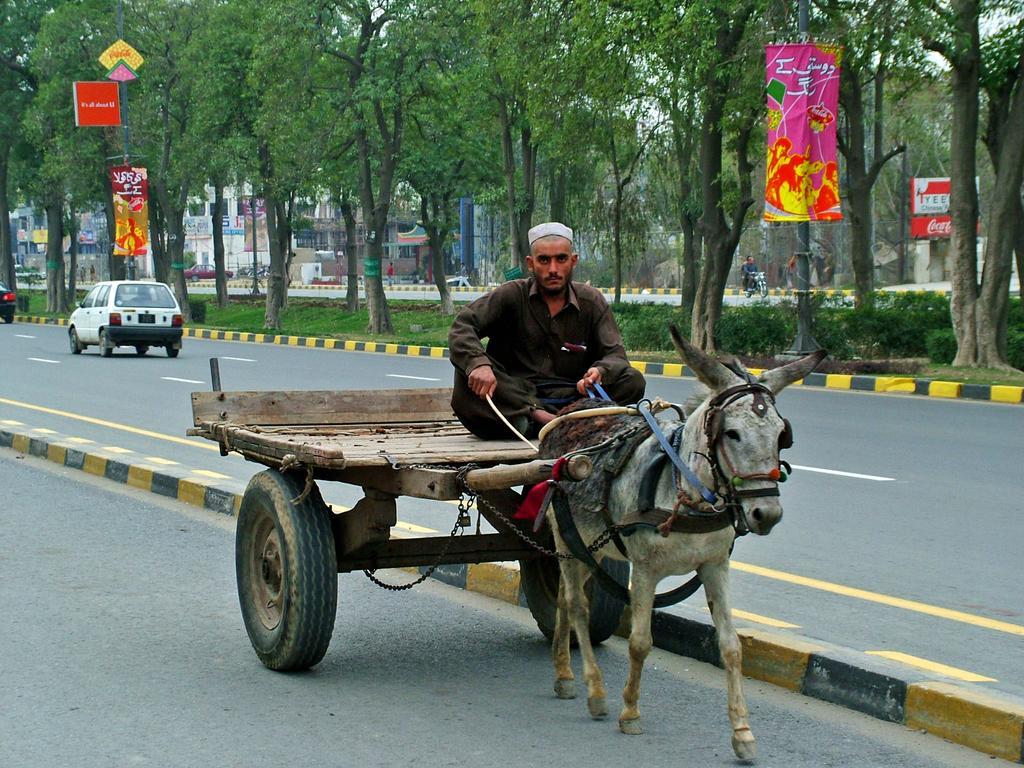In one or two sentences, can you explain what this image depicts? In this picture we can see a horse cart with a person on it on the road, here we can see vehicles, people, banners, posters and in the background we can see buildings, trees, plants and some objects. 